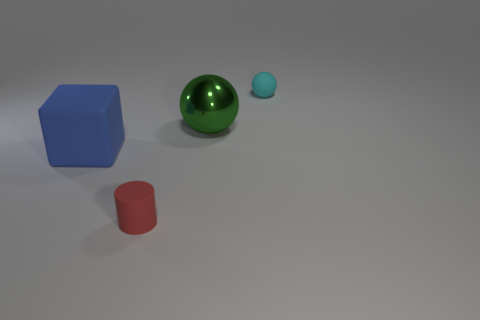What number of other things are there of the same shape as the tiny cyan rubber object?
Provide a short and direct response. 1. Are there fewer big green metal spheres behind the big matte object than large green shiny things that are behind the metal thing?
Ensure brevity in your answer.  No. Is there anything else that has the same material as the green sphere?
Give a very brief answer. No. There is a blue thing that is made of the same material as the tiny sphere; what is its shape?
Offer a very short reply. Cube. Are there any other things that are the same color as the metallic ball?
Your answer should be compact. No. There is a large object that is to the left of the small matte thing that is in front of the rubber block; what is its color?
Your response must be concise. Blue. What material is the thing that is behind the sphere left of the small thing behind the large green metal object?
Keep it short and to the point. Rubber. How many red cylinders are the same size as the cyan matte ball?
Give a very brief answer. 1. There is a thing that is in front of the big green object and behind the tiny red cylinder; what material is it?
Provide a succinct answer. Rubber. What number of red rubber cylinders are to the right of the tiny red rubber cylinder?
Offer a terse response. 0. 